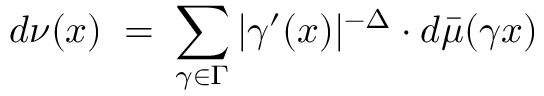<formula> <loc_0><loc_0><loc_500><loc_500>d \nu ( x ) \, = \, \sum _ { \gamma \in \Gamma } | \gamma ^ { \prime } ( x ) | ^ { - \Delta } \cdot d \bar { \mu } ( \gamma x )</formula> 